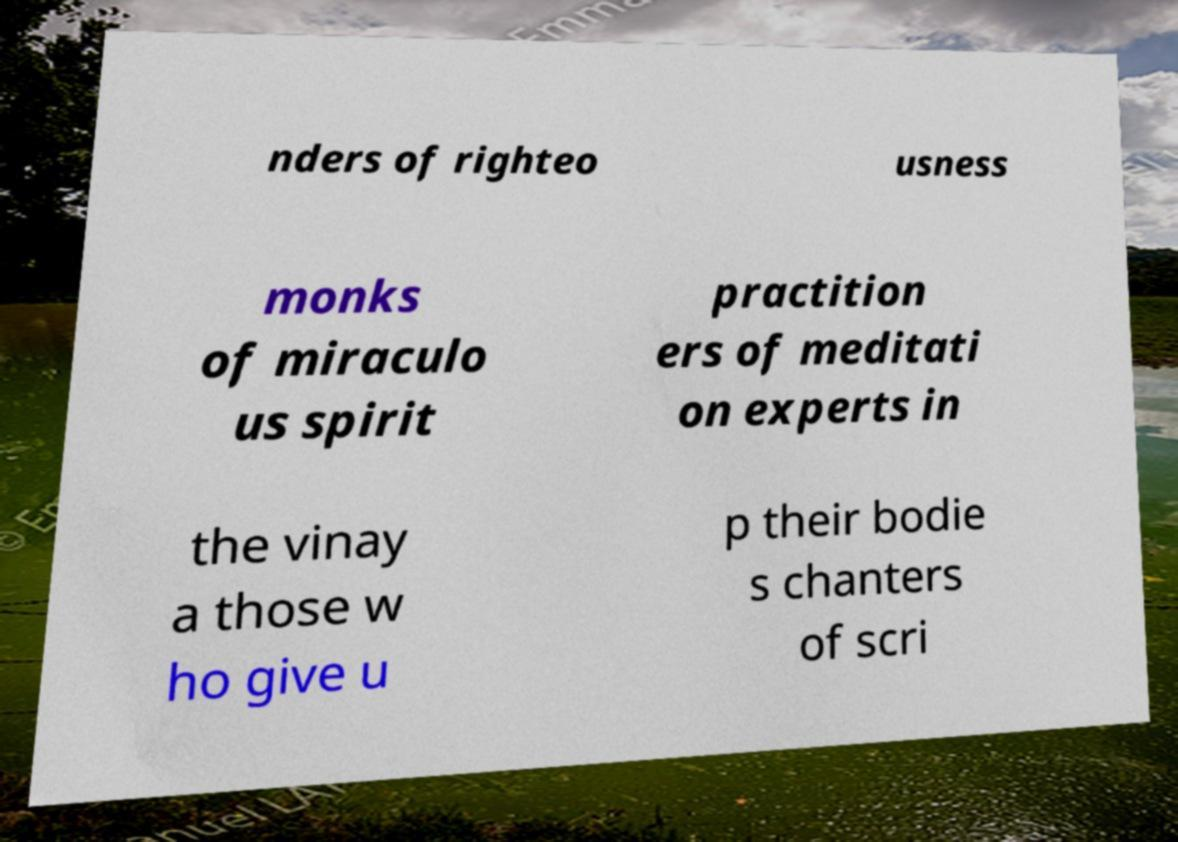For documentation purposes, I need the text within this image transcribed. Could you provide that? nders of righteo usness monks of miraculo us spirit practition ers of meditati on experts in the vinay a those w ho give u p their bodie s chanters of scri 